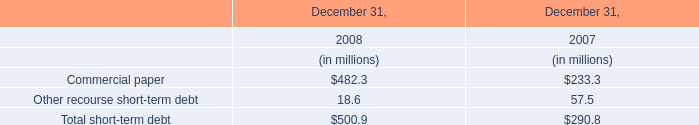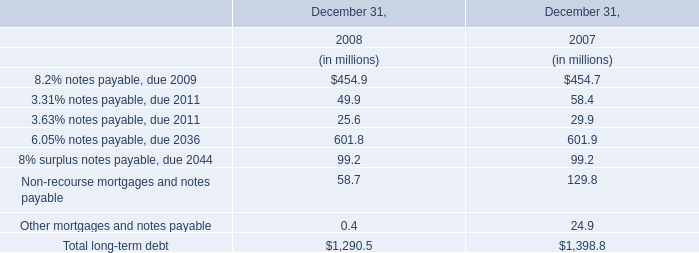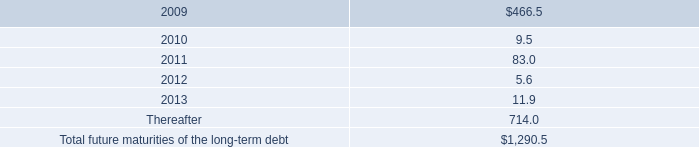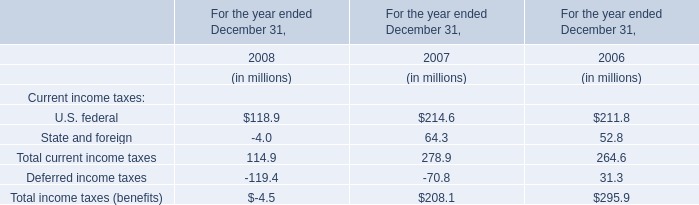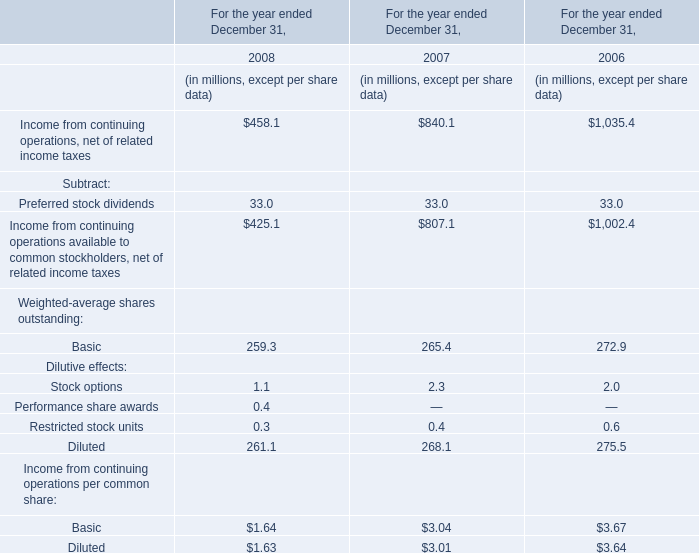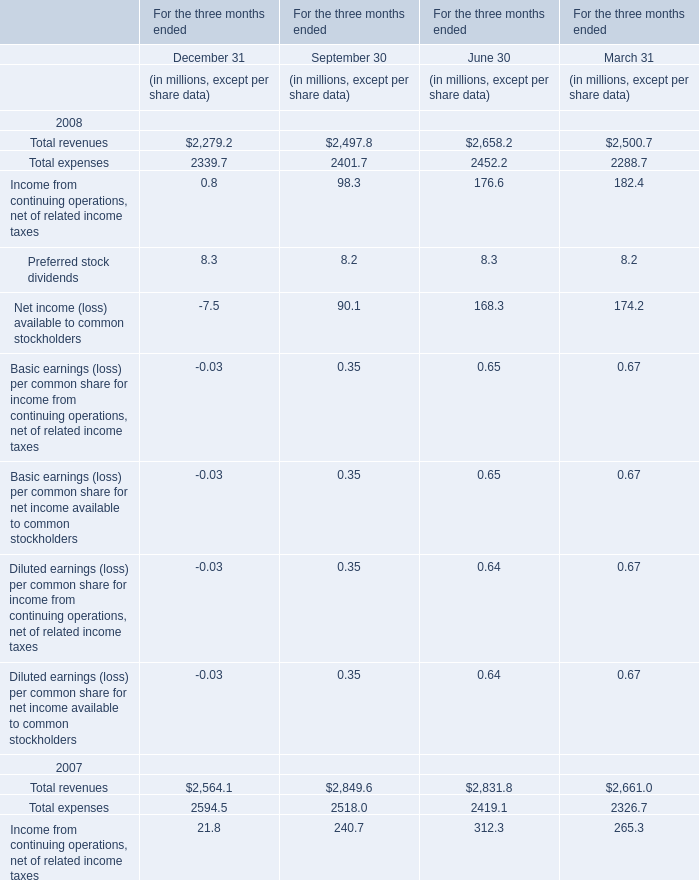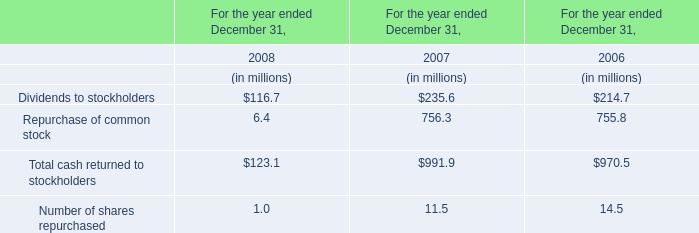Which year is the value of Total expenses for the three months ended September 30 the least? 
Answer: 2008. 